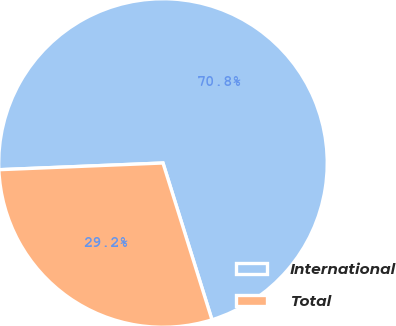<chart> <loc_0><loc_0><loc_500><loc_500><pie_chart><fcel>International<fcel>Total<nl><fcel>70.83%<fcel>29.17%<nl></chart> 